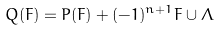<formula> <loc_0><loc_0><loc_500><loc_500>Q ( F ) = P ( F ) + ( - 1 ) ^ { n + 1 } F \cup \Lambda</formula> 